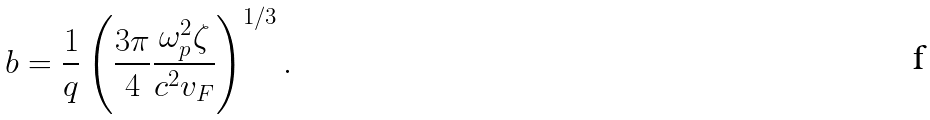<formula> <loc_0><loc_0><loc_500><loc_500>b = \frac { 1 } { q } \left ( \frac { 3 \pi } { 4 } \frac { \omega _ { p } ^ { 2 } \zeta } { c ^ { 2 } v _ { F } } \right ) ^ { 1 / 3 } .</formula> 